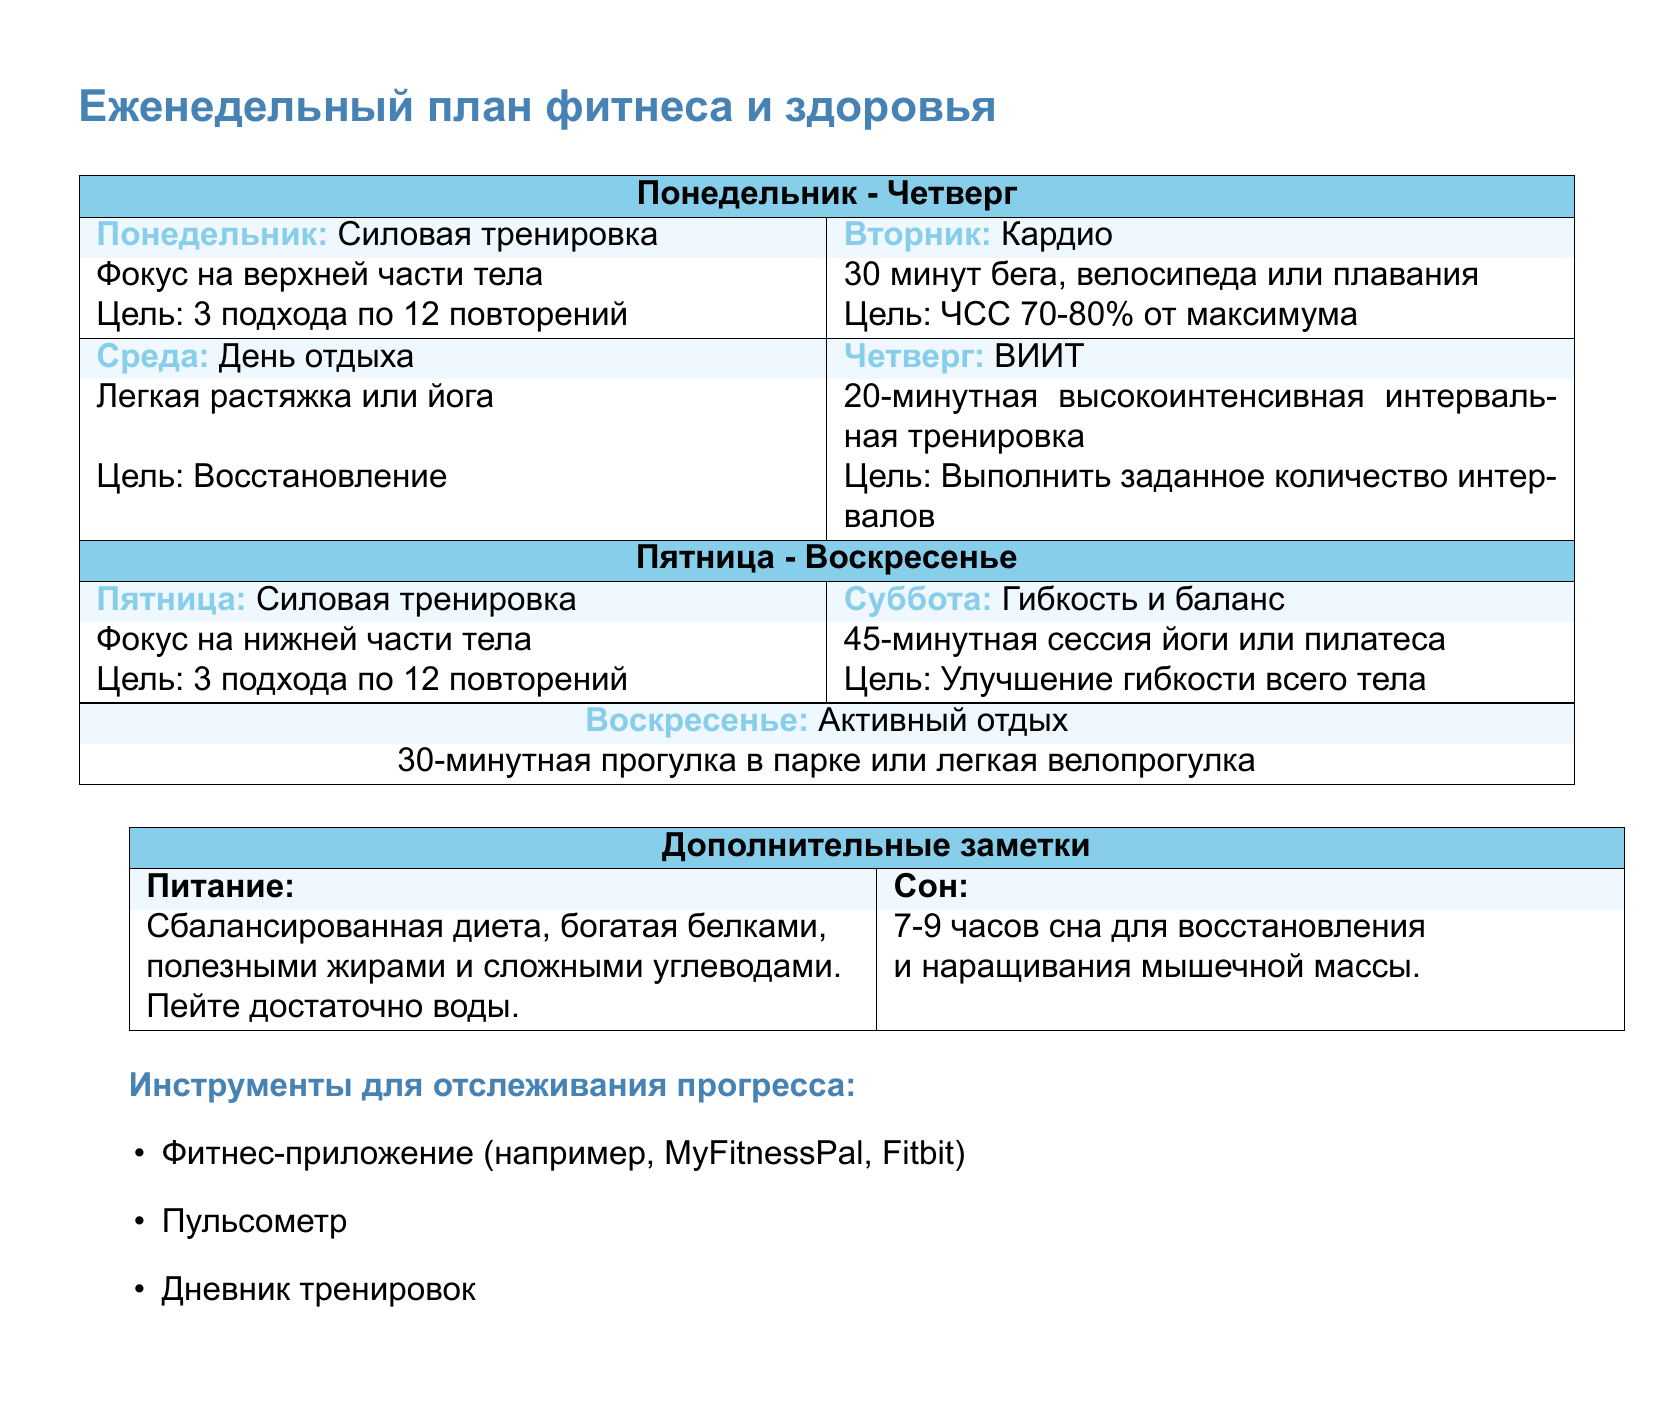Какой день предназначен для силовой тренировки? В документе указано, что силовая тренировка проходит в понедельник и пятницу.
Answer: Понедельник и пятница Сколько времени занимает кардио на вторник? В документе указано, что кардио состоит из 30 минут бега, велосипеда или плавания.
Answer: 30 минут Какой тип тренировки предлагается на четверг? Четверг включает в себя высокоинтенсивную интервальную тренировку (ВИИТ).
Answer: ВИИТ Сколько подходов по 12 повторений рекомендовано для силовых тренировок? Документ указывает, что для силовых тренировок рекомендуется выполнять 3 подхода по 12 повторений.
Answer: 3 подхода Что рекомендуется делать в день отдыха? В среду рекомендуется легкая растяжка или йога для восстановления.
Answer: Легкая растяжка или йога Какой основной акцент в тренировке на пятницу? В документе указано, что акцент на пятницу — это тренировка нижней части тела.
Answer: Нижней части тела Сколько часов сна рекомендуется для восстановления? Рекомендуется 7-9 часов сна для восстановления и наращивания мышечной массы.
Answer: 7-9 часов Какой инструмент для отслеживания прогресса включает в себя пульсометр? В документе упоминается пульсометр как один из инструментов для отслеживания прогресса.
Answer: Пульсометр Какого рода упражнения предлагаются на субботу? В субботу предлагается сессия йоги или пилатеса для гибкости и баланса.
Answer: Йога или пилатес 